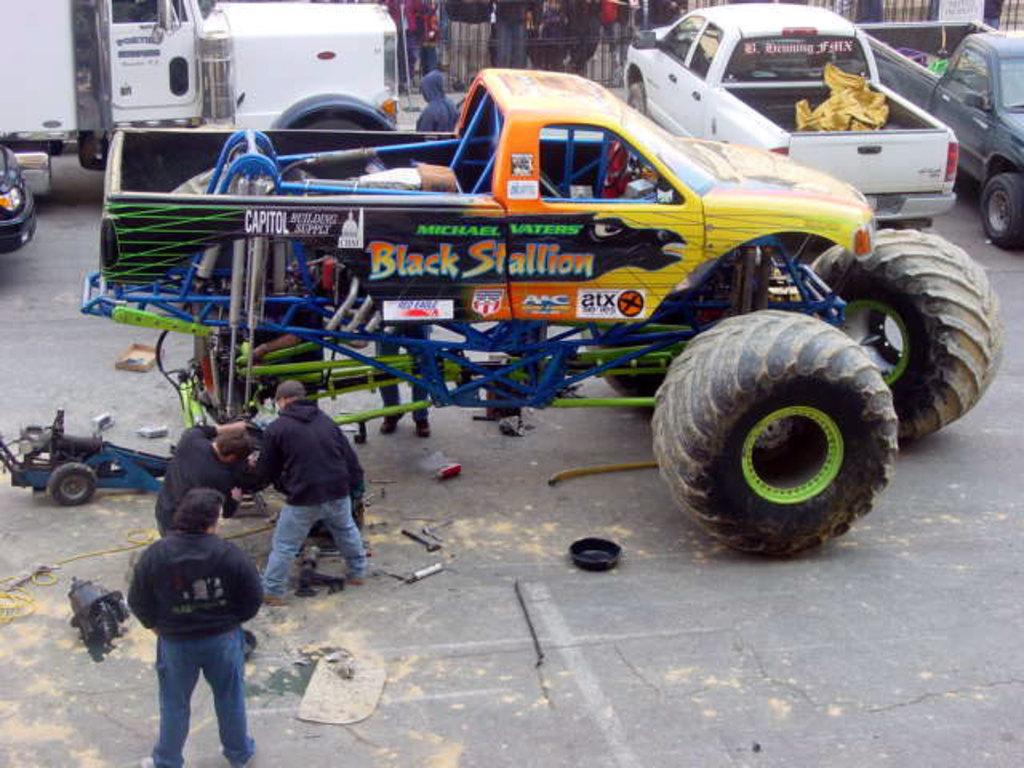<image>
Write a terse but informative summary of the picture. The name of the truck being worked on is the Black Stallion. 